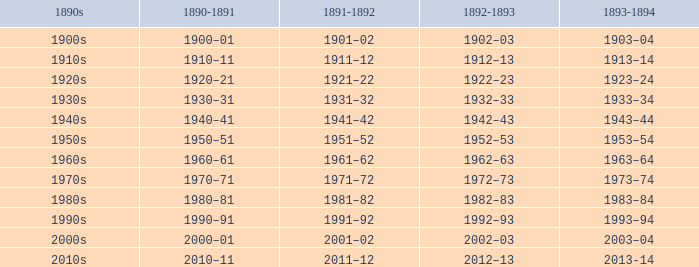What is the year from 1892-93 that has the 1890s to the 1940s? 1942–43. 